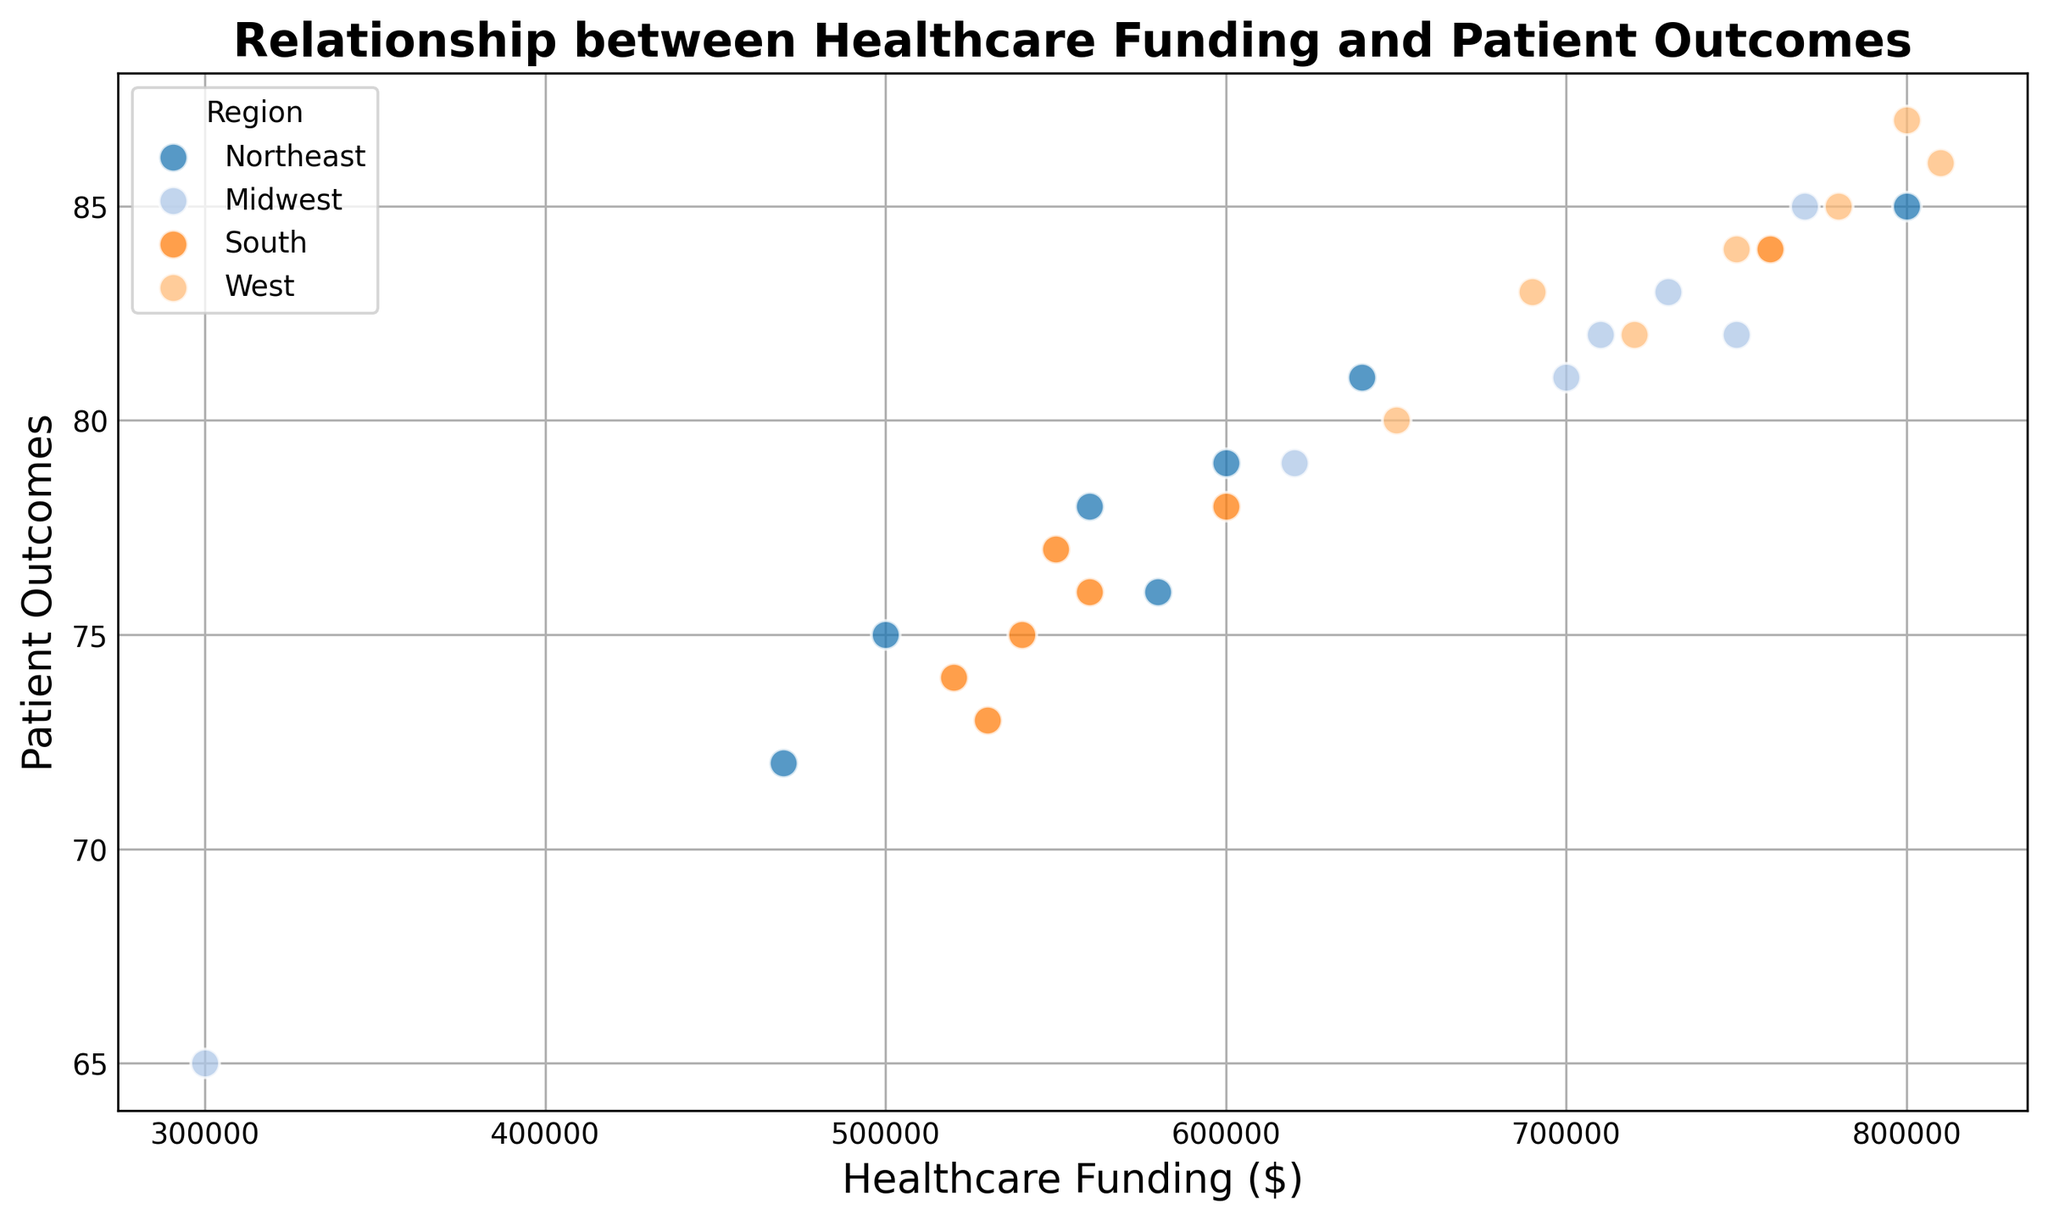What's the average value of Patient Outcomes for hospitals in the West region? First, identify all the data points from the West region: 80, 82, 86, 83, 85, 87, 84, 85. Sum them up: 80 + 82 + 86 + 83 + 85 + 87 + 84 + 85 = 672. Then, divide by the number of data points (8): 672 / 8 = 84
Answer: 84 Which region has the highest Patient Outcome for a hospital? Identify the highest Patient Outcome on the Y-axis across all regions. Here, the highest value is 87, which corresponds to a hospital in the West region.
Answer: West Do hospitals with higher Healthcare Funding generally have better Patient Outcomes? Observing the scatter plot, there appears to be a trend where higher funding is associated with higher patient outcomes, as seen by the upward direction of the data points.
Answer: Yes Is there any region where lower Healthcare Funding still achieves relatively high Patient Outcomes? Check for data points with lower X-axis values (Healthcare Funding) that have higher Y-axis values (Patient Outcomes). For instance, in the Midwest region, $560,000 in funding corresponds to a Patient Outcome of 78, which is relatively high.
Answer: Midwest What is the range of Healthcare Funding values for the Northeast region? Identify the minimum and maximum values of Healthcare Funding for the Northeast region's data points. The values range from $470,000 to $800,000.
Answer: $470,000 to $800,000 Which region has the most diverse range of Patient Outcomes? Look for the region with the maximum spread in Y-axis values. Calculating the range for each region, West has values from 80 to 87, indicating it has a wide range.
Answer: West Compare the average Patient Outcomes between the Northeast and Midwest regions. Which is higher, and by how much? Calculate the average for both regions. Northeast: (75+85+72+76+81+74+78+79) / 8 = 77.5, Midwest: (82+65+79+81+85+82+83+83) / 8 = 81. Calculate the difference: 81 - 77.5 = 3.5. The Midwest has a higher average by 3.5 points.
Answer: Midwest by 3.5 What color is used to represent the South region? Identify the distinct colors used in the scatter plot legend for the South region. The South region is represented by the third color, which is likely a separate shade different from the other regions.
Answer: (Identify from visual plot; this answer would be the specific color seen in the legend) 